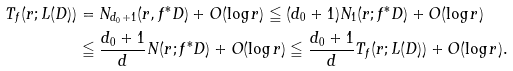<formula> <loc_0><loc_0><loc_500><loc_500>T _ { f } ( r ; L ( D ) ) & = N _ { d _ { 0 } + 1 } ( r , f ^ { * } D ) + O ( \log r ) \leqq ( d _ { 0 } + 1 ) N _ { 1 } ( r ; f ^ { * } D ) + O ( \log r ) \\ & \leqq \frac { d _ { 0 } + 1 } { d } N ( r ; f ^ { * } D ) + O ( \log r ) \leqq \frac { d _ { 0 } + 1 } { d } T _ { f } ( r ; L ( D ) ) + O ( \log r ) .</formula> 